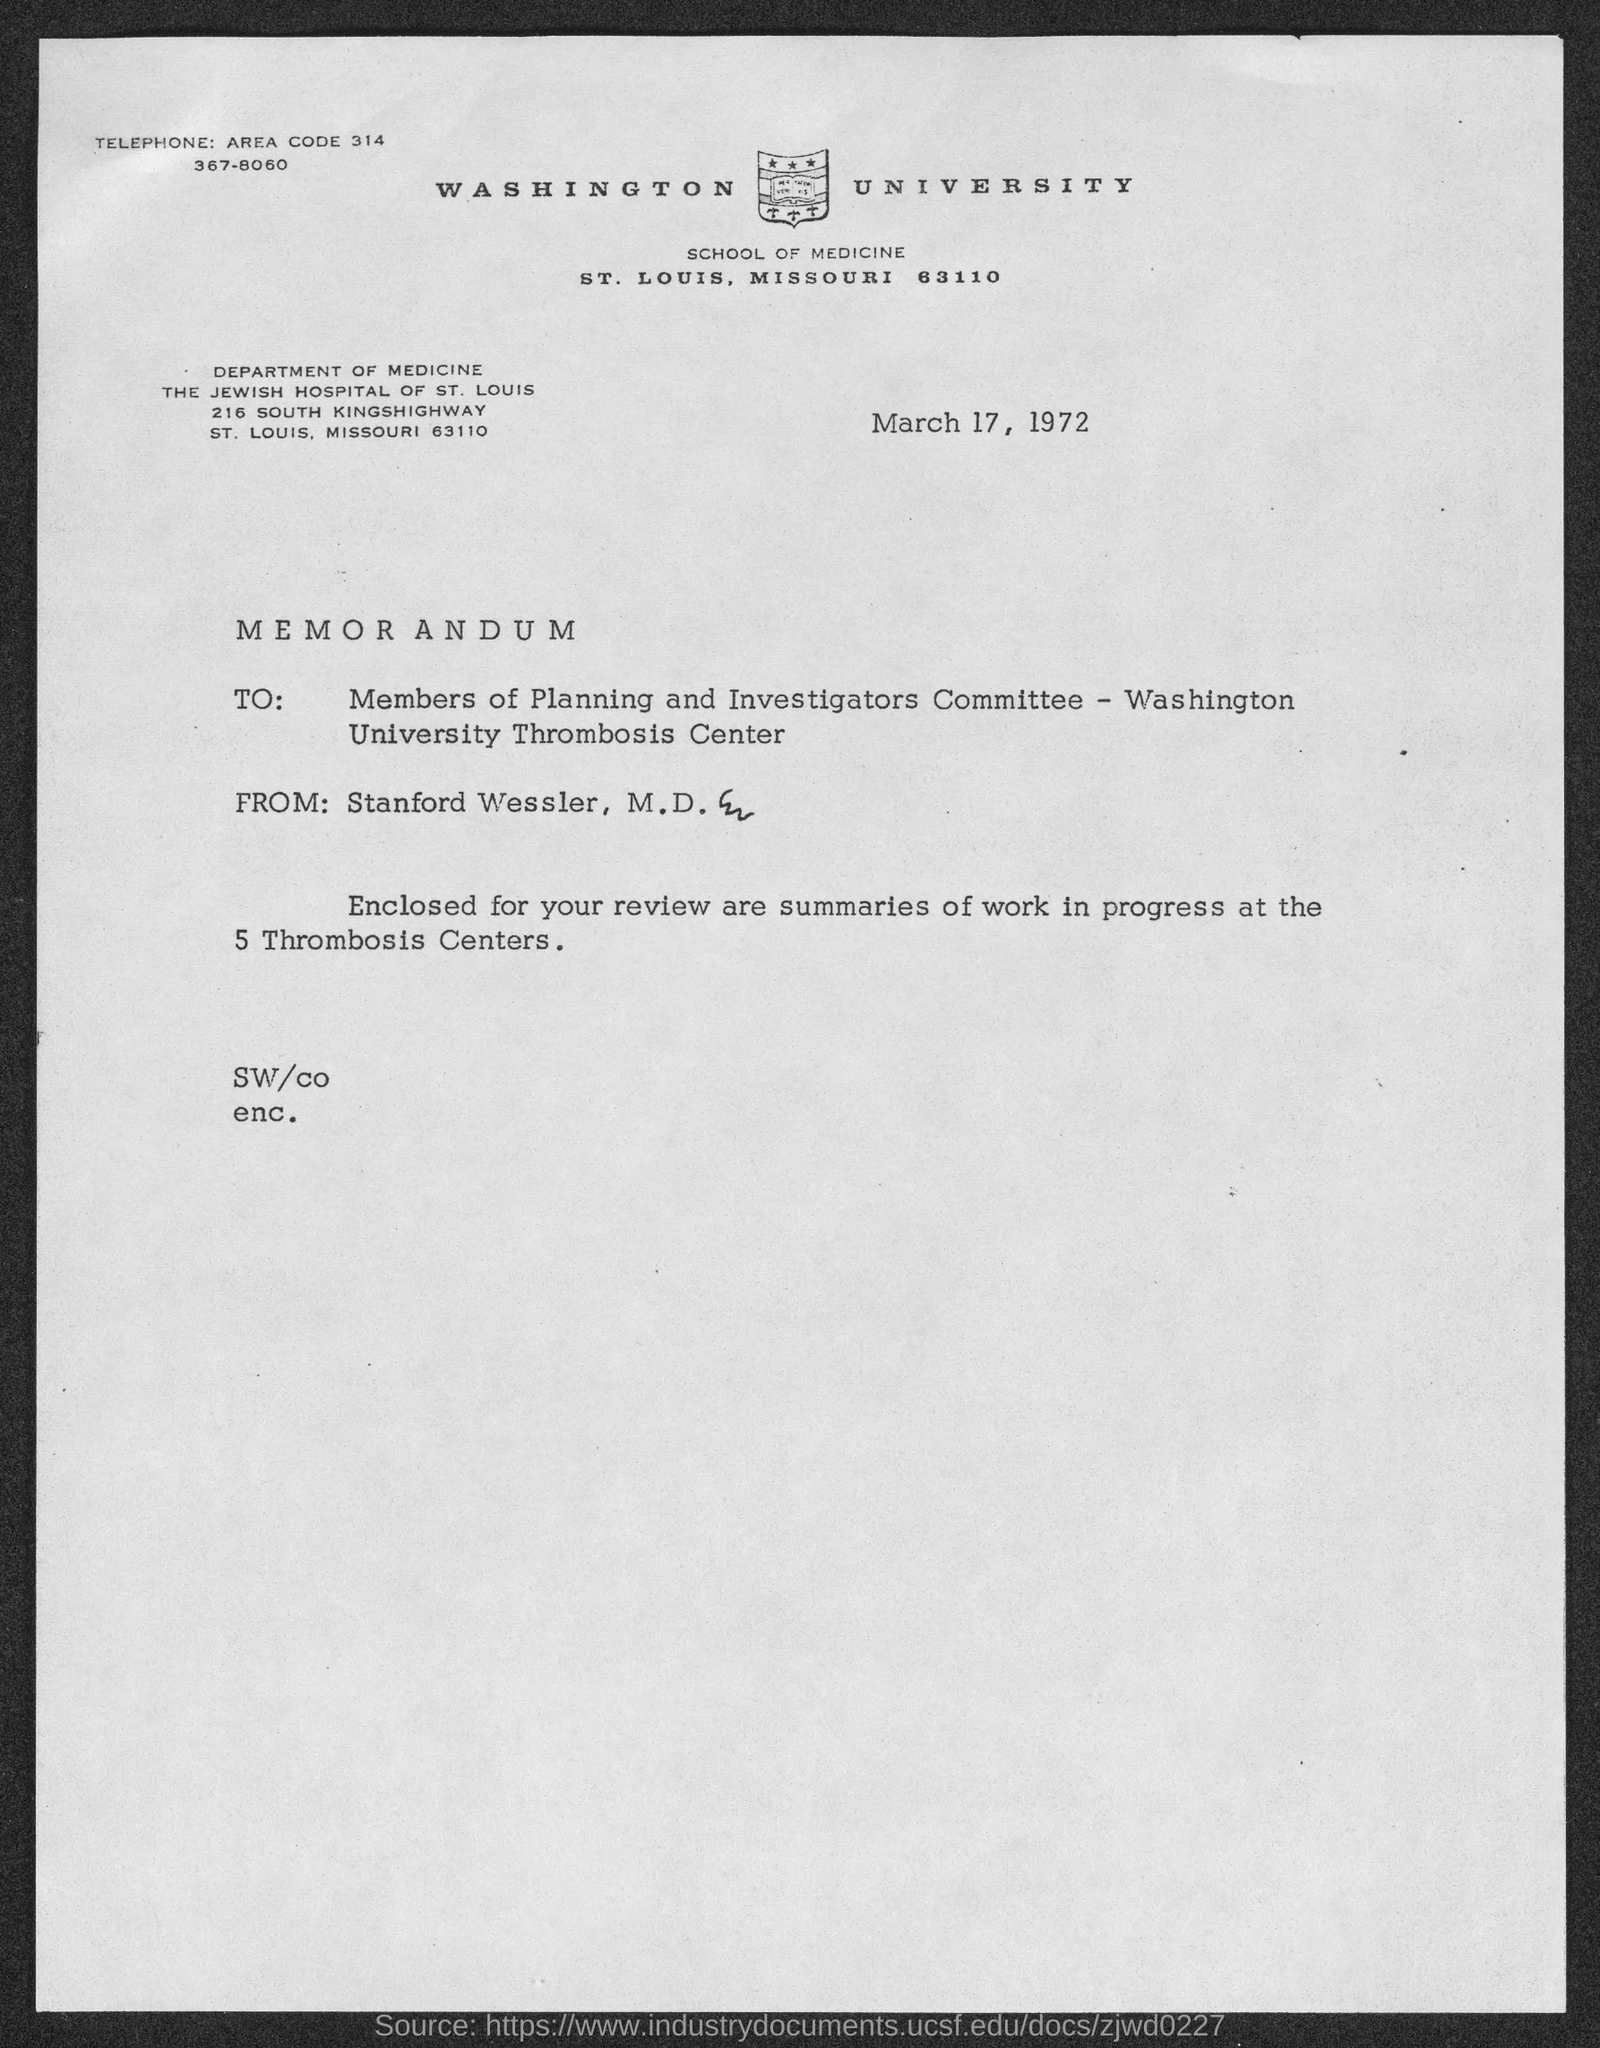Mention a couple of crucial points in this snapshot. Washington University is located in St. Louis County. The Jewish Hospital of St. Louis is located at 216 South Kingshighway. The memorandum is dated March 17, 1972. The telephone number of Washington University is 314 367-8060. The area code is 314... 